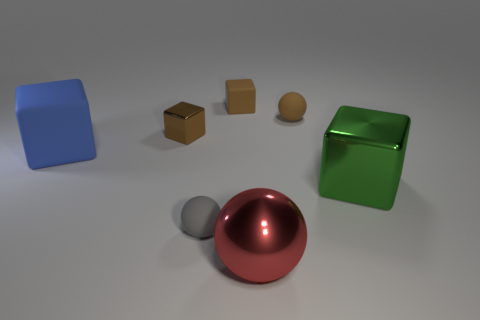Is there any other thing that has the same color as the large rubber object?
Provide a succinct answer. No. Is the red ball the same size as the gray rubber ball?
Make the answer very short. No. Are there any big purple rubber cylinders?
Your answer should be very brief. No. What is the shape of the large thing to the right of the brown matte sphere?
Provide a succinct answer. Cube. How many small matte spheres are both behind the tiny brown shiny block and left of the large red ball?
Offer a terse response. 0. Is there a brown object that has the same material as the big sphere?
Your answer should be compact. Yes. What number of cubes are brown things or big blue objects?
Give a very brief answer. 3. What size is the green thing?
Provide a succinct answer. Large. What number of small gray things are on the left side of the brown rubber block?
Offer a very short reply. 1. There is a object that is left of the metal cube behind the blue matte object; what is its size?
Your answer should be compact. Large. 